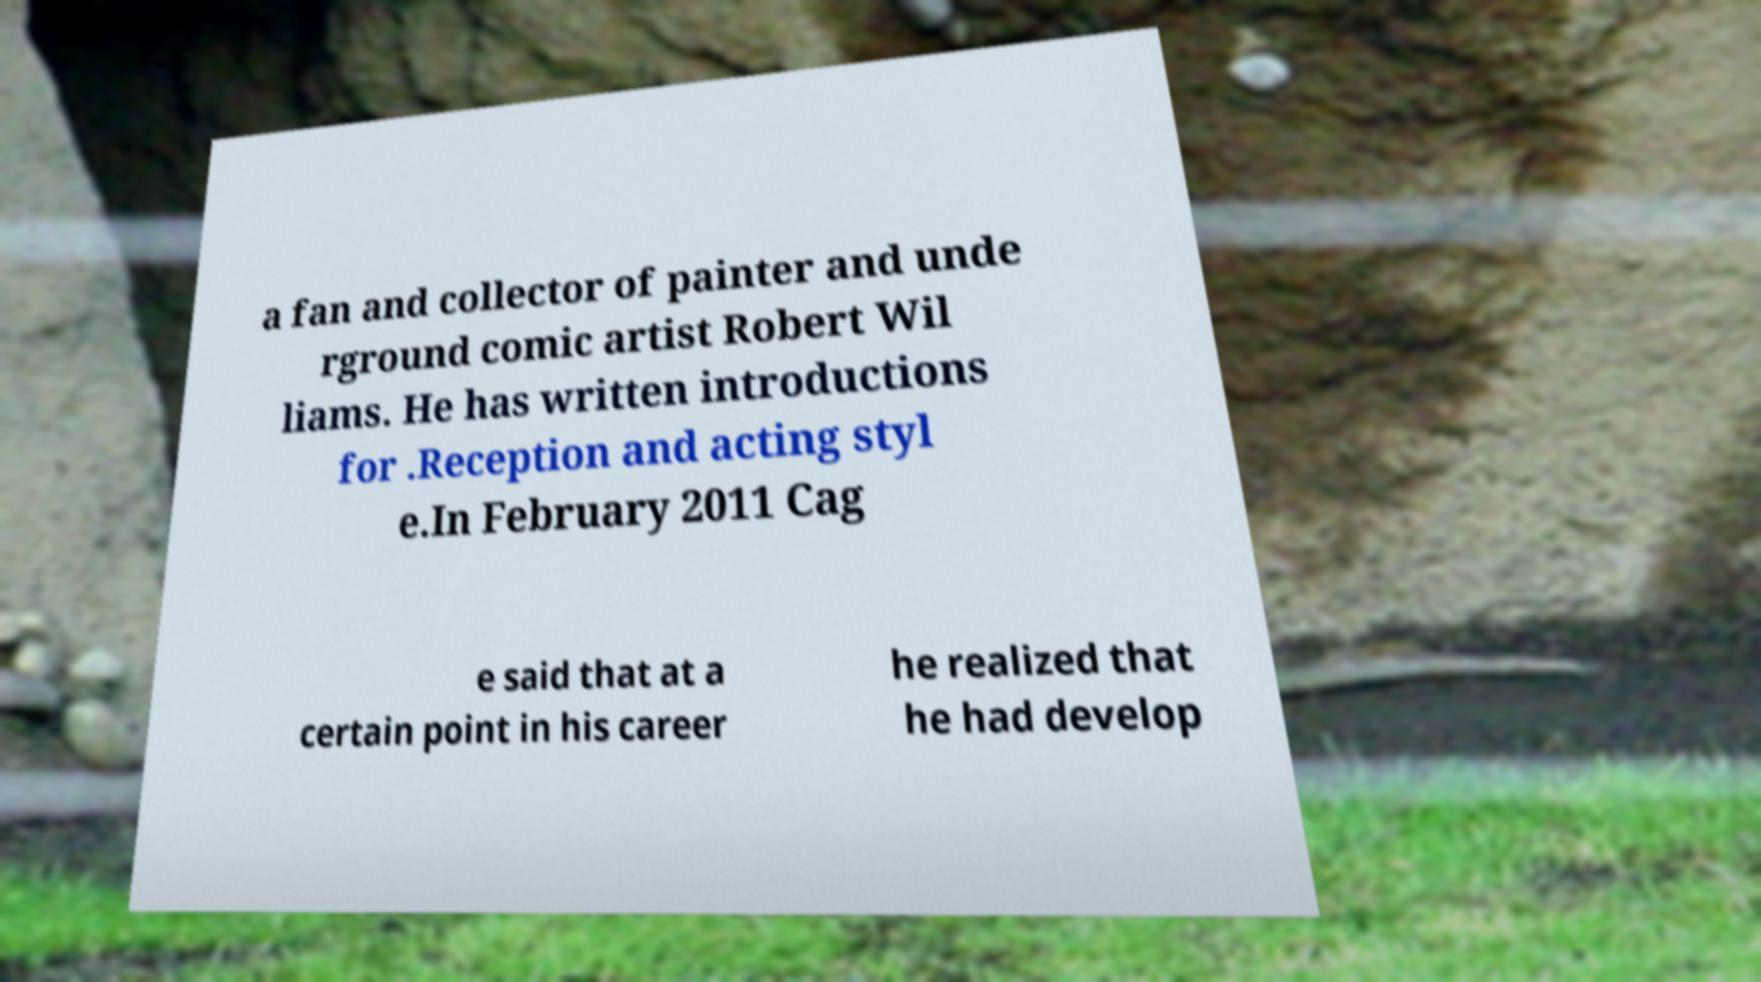For documentation purposes, I need the text within this image transcribed. Could you provide that? a fan and collector of painter and unde rground comic artist Robert Wil liams. He has written introductions for .Reception and acting styl e.In February 2011 Cag e said that at a certain point in his career he realized that he had develop 